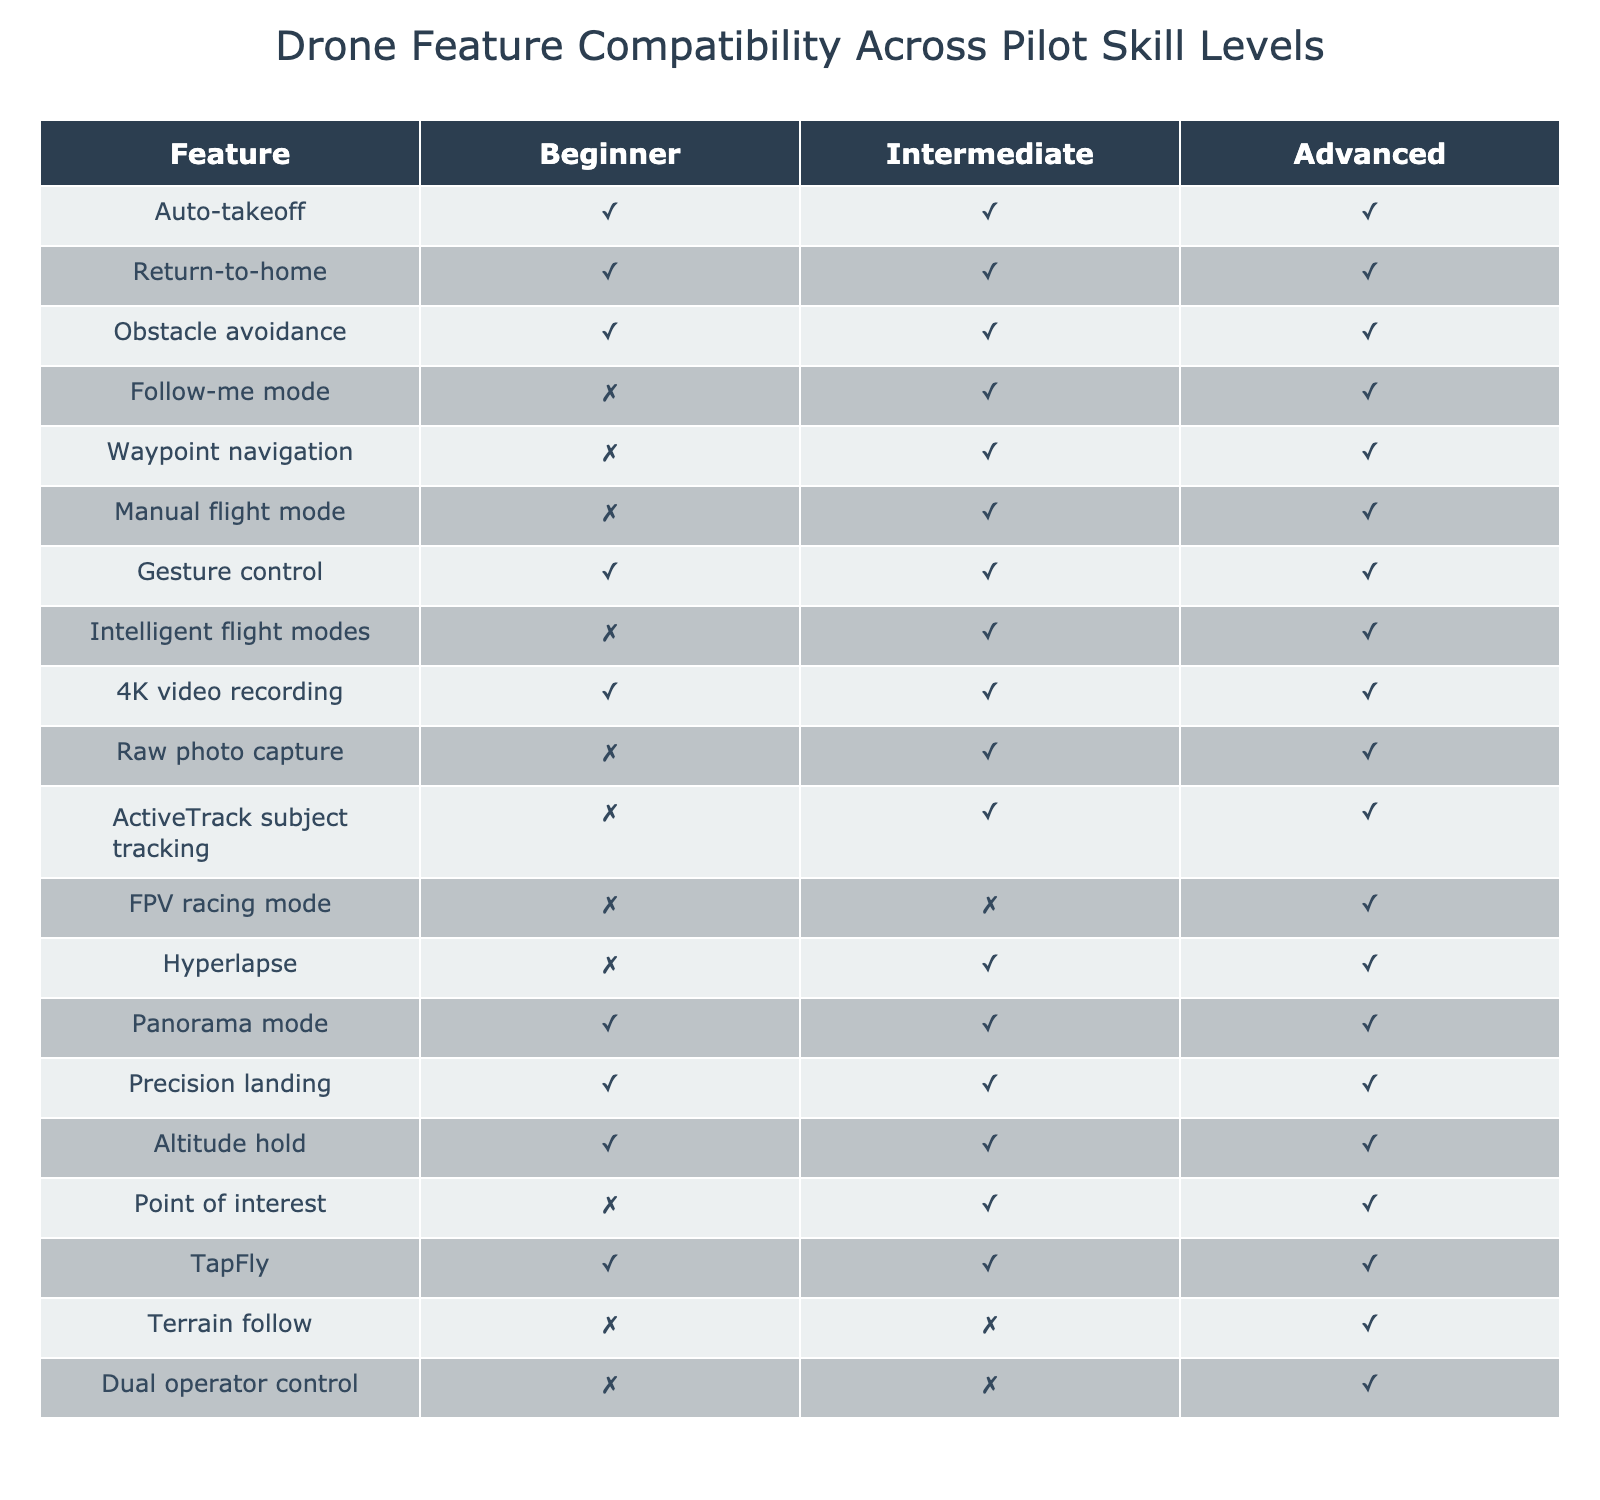What features are available for beginner pilots? To find the features available for beginner pilots, I look at the 'Beginner' column of the table and identify all rows with a value of 1. The available features are Auto-takeoff, Return-to-home, Obstacle avoidance, Gesture control, 4K video recording, Panorama mode, Precision landing, Altitude hold, and TapFly.
Answer: Auto-takeoff, Return-to-home, Obstacle avoidance, Gesture control, 4K video recording, Panorama mode, Precision landing, Altitude hold, TapFly Which features are not available for intermediate pilots? I check the 'Intermediate' column of the table and look for rows with a value of 0. The features that are not available for intermediate pilots are Follow-me mode, Waypoint navigation, Manual flight mode, FPV racing mode, and Terrain follow.
Answer: Follow-me mode, Waypoint navigation, Manual flight mode, FPV racing mode, Terrain follow How many features are available for advanced pilots? I count all features in the 'Advanced' column that have a value of 1. There are 10 features available for advanced pilots: Auto-takeoff, Return-to-home, Obstacle avoidance, Follow-me mode, Waypoint navigation, Manual flight mode, Gesture control, Intelligent flight modes, 4K video recording, Raw photo capture, ActiveTrack subject tracking, FPV racing mode, Hyperlapse, Panorama mode, Precision landing, Altitude hold, Point of interest, TapFly, Terrain follow, and Dual operator control. After counting, only those with 1 are included — resulting in a total of 10.
Answer: 10 Is Gesture control available across all skill levels? I look at the 'Gesture control' row and check the corresponding values in all skill level columns. Since Gesture control has a value of 1 in Beginner, Intermediate, and Advanced columns, it is available across all skill levels.
Answer: Yes Which features do not require advanced skills? To identify features not requiring advanced skills, I search for the features in the 'Beginner' and 'Intermediate' columns with a value of 1. The features found are: Auto-takeoff, Return-to-home, Obstacle avoidance, Gesture control, 4K video recording, Panorama mode, Precision landing, Altitude hold, TapFly, and others. Altogether, this shows inclusion in beginner or intermediate levels. After counting, 10 features are noted.
Answer: 10 features 